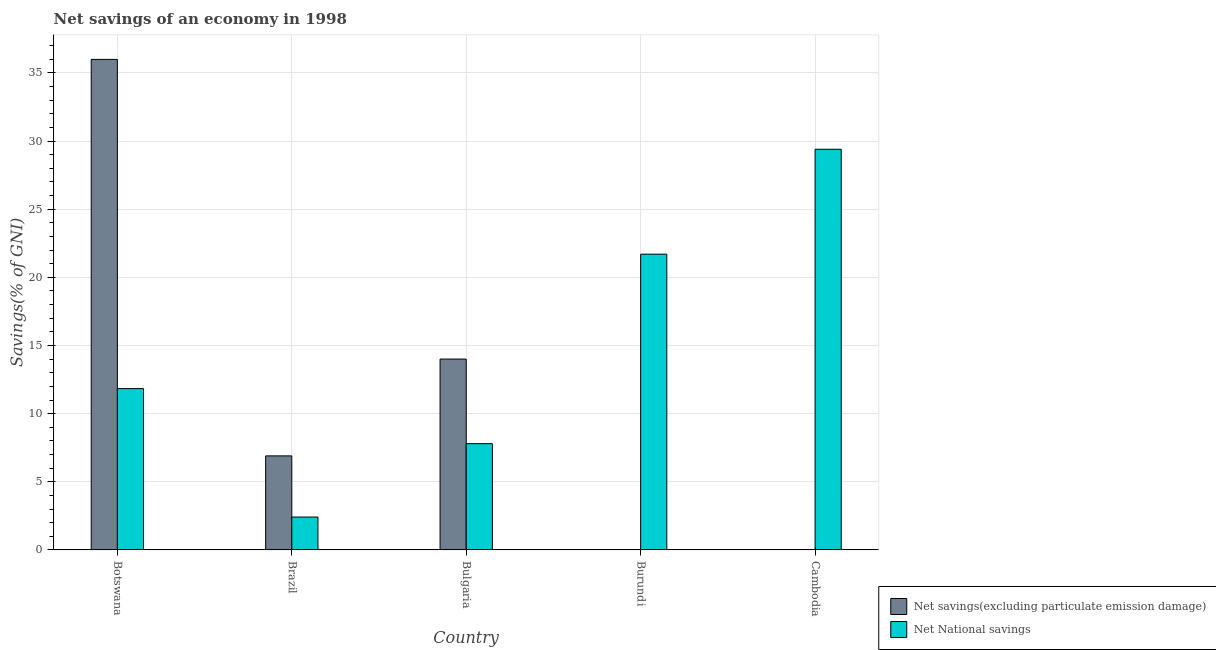How many different coloured bars are there?
Ensure brevity in your answer.  2. How many bars are there on the 3rd tick from the right?
Your answer should be very brief. 2. What is the net national savings in Brazil?
Make the answer very short. 2.41. Across all countries, what is the maximum net savings(excluding particulate emission damage)?
Make the answer very short. 35.99. In which country was the net national savings maximum?
Provide a short and direct response. Cambodia. What is the total net savings(excluding particulate emission damage) in the graph?
Offer a terse response. 56.89. What is the difference between the net national savings in Brazil and that in Bulgaria?
Your answer should be compact. -5.38. What is the difference between the net savings(excluding particulate emission damage) in Cambodia and the net national savings in Bulgaria?
Your answer should be compact. -7.8. What is the average net savings(excluding particulate emission damage) per country?
Your answer should be very brief. 11.38. What is the difference between the net savings(excluding particulate emission damage) and net national savings in Botswana?
Ensure brevity in your answer.  24.15. In how many countries, is the net national savings greater than 18 %?
Your answer should be compact. 2. What is the ratio of the net national savings in Botswana to that in Bulgaria?
Ensure brevity in your answer.  1.52. Is the net national savings in Bulgaria less than that in Cambodia?
Offer a terse response. Yes. What is the difference between the highest and the second highest net national savings?
Your answer should be very brief. 7.7. What is the difference between the highest and the lowest net national savings?
Your answer should be compact. 26.99. In how many countries, is the net savings(excluding particulate emission damage) greater than the average net savings(excluding particulate emission damage) taken over all countries?
Ensure brevity in your answer.  2. Is the sum of the net national savings in Brazil and Burundi greater than the maximum net savings(excluding particulate emission damage) across all countries?
Ensure brevity in your answer.  No. How many bars are there?
Your answer should be very brief. 8. Are all the bars in the graph horizontal?
Offer a terse response. No. How many countries are there in the graph?
Ensure brevity in your answer.  5. What is the difference between two consecutive major ticks on the Y-axis?
Offer a very short reply. 5. Are the values on the major ticks of Y-axis written in scientific E-notation?
Provide a succinct answer. No. Does the graph contain grids?
Ensure brevity in your answer.  Yes. How many legend labels are there?
Your answer should be very brief. 2. How are the legend labels stacked?
Make the answer very short. Vertical. What is the title of the graph?
Ensure brevity in your answer.  Net savings of an economy in 1998. What is the label or title of the X-axis?
Your answer should be compact. Country. What is the label or title of the Y-axis?
Give a very brief answer. Savings(% of GNI). What is the Savings(% of GNI) of Net savings(excluding particulate emission damage) in Botswana?
Provide a succinct answer. 35.99. What is the Savings(% of GNI) of Net National savings in Botswana?
Ensure brevity in your answer.  11.84. What is the Savings(% of GNI) of Net savings(excluding particulate emission damage) in Brazil?
Your answer should be compact. 6.9. What is the Savings(% of GNI) in Net National savings in Brazil?
Provide a short and direct response. 2.41. What is the Savings(% of GNI) in Net savings(excluding particulate emission damage) in Bulgaria?
Provide a succinct answer. 14. What is the Savings(% of GNI) in Net National savings in Bulgaria?
Make the answer very short. 7.8. What is the Savings(% of GNI) in Net National savings in Burundi?
Your answer should be very brief. 21.7. What is the Savings(% of GNI) in Net National savings in Cambodia?
Provide a succinct answer. 29.4. Across all countries, what is the maximum Savings(% of GNI) in Net savings(excluding particulate emission damage)?
Keep it short and to the point. 35.99. Across all countries, what is the maximum Savings(% of GNI) in Net National savings?
Make the answer very short. 29.4. Across all countries, what is the minimum Savings(% of GNI) in Net National savings?
Offer a terse response. 2.41. What is the total Savings(% of GNI) in Net savings(excluding particulate emission damage) in the graph?
Give a very brief answer. 56.89. What is the total Savings(% of GNI) of Net National savings in the graph?
Offer a very short reply. 73.14. What is the difference between the Savings(% of GNI) in Net savings(excluding particulate emission damage) in Botswana and that in Brazil?
Ensure brevity in your answer.  29.09. What is the difference between the Savings(% of GNI) in Net National savings in Botswana and that in Brazil?
Provide a short and direct response. 9.42. What is the difference between the Savings(% of GNI) of Net savings(excluding particulate emission damage) in Botswana and that in Bulgaria?
Provide a succinct answer. 21.99. What is the difference between the Savings(% of GNI) of Net National savings in Botswana and that in Bulgaria?
Your answer should be compact. 4.04. What is the difference between the Savings(% of GNI) in Net National savings in Botswana and that in Burundi?
Your answer should be compact. -9.86. What is the difference between the Savings(% of GNI) in Net National savings in Botswana and that in Cambodia?
Your answer should be very brief. -17.56. What is the difference between the Savings(% of GNI) in Net savings(excluding particulate emission damage) in Brazil and that in Bulgaria?
Make the answer very short. -7.1. What is the difference between the Savings(% of GNI) in Net National savings in Brazil and that in Bulgaria?
Keep it short and to the point. -5.38. What is the difference between the Savings(% of GNI) in Net National savings in Brazil and that in Burundi?
Your answer should be compact. -19.29. What is the difference between the Savings(% of GNI) in Net National savings in Brazil and that in Cambodia?
Your answer should be very brief. -26.99. What is the difference between the Savings(% of GNI) in Net National savings in Bulgaria and that in Burundi?
Ensure brevity in your answer.  -13.9. What is the difference between the Savings(% of GNI) of Net National savings in Bulgaria and that in Cambodia?
Make the answer very short. -21.6. What is the difference between the Savings(% of GNI) in Net National savings in Burundi and that in Cambodia?
Provide a short and direct response. -7.7. What is the difference between the Savings(% of GNI) of Net savings(excluding particulate emission damage) in Botswana and the Savings(% of GNI) of Net National savings in Brazil?
Ensure brevity in your answer.  33.58. What is the difference between the Savings(% of GNI) in Net savings(excluding particulate emission damage) in Botswana and the Savings(% of GNI) in Net National savings in Bulgaria?
Offer a very short reply. 28.19. What is the difference between the Savings(% of GNI) of Net savings(excluding particulate emission damage) in Botswana and the Savings(% of GNI) of Net National savings in Burundi?
Ensure brevity in your answer.  14.29. What is the difference between the Savings(% of GNI) in Net savings(excluding particulate emission damage) in Botswana and the Savings(% of GNI) in Net National savings in Cambodia?
Offer a very short reply. 6.59. What is the difference between the Savings(% of GNI) of Net savings(excluding particulate emission damage) in Brazil and the Savings(% of GNI) of Net National savings in Bulgaria?
Your answer should be compact. -0.9. What is the difference between the Savings(% of GNI) in Net savings(excluding particulate emission damage) in Brazil and the Savings(% of GNI) in Net National savings in Burundi?
Make the answer very short. -14.8. What is the difference between the Savings(% of GNI) in Net savings(excluding particulate emission damage) in Brazil and the Savings(% of GNI) in Net National savings in Cambodia?
Offer a terse response. -22.5. What is the difference between the Savings(% of GNI) in Net savings(excluding particulate emission damage) in Bulgaria and the Savings(% of GNI) in Net National savings in Burundi?
Provide a succinct answer. -7.7. What is the difference between the Savings(% of GNI) in Net savings(excluding particulate emission damage) in Bulgaria and the Savings(% of GNI) in Net National savings in Cambodia?
Ensure brevity in your answer.  -15.39. What is the average Savings(% of GNI) of Net savings(excluding particulate emission damage) per country?
Provide a succinct answer. 11.38. What is the average Savings(% of GNI) in Net National savings per country?
Ensure brevity in your answer.  14.63. What is the difference between the Savings(% of GNI) in Net savings(excluding particulate emission damage) and Savings(% of GNI) in Net National savings in Botswana?
Offer a terse response. 24.15. What is the difference between the Savings(% of GNI) of Net savings(excluding particulate emission damage) and Savings(% of GNI) of Net National savings in Brazil?
Offer a terse response. 4.49. What is the difference between the Savings(% of GNI) in Net savings(excluding particulate emission damage) and Savings(% of GNI) in Net National savings in Bulgaria?
Ensure brevity in your answer.  6.21. What is the ratio of the Savings(% of GNI) of Net savings(excluding particulate emission damage) in Botswana to that in Brazil?
Ensure brevity in your answer.  5.22. What is the ratio of the Savings(% of GNI) in Net National savings in Botswana to that in Brazil?
Provide a short and direct response. 4.91. What is the ratio of the Savings(% of GNI) of Net savings(excluding particulate emission damage) in Botswana to that in Bulgaria?
Provide a short and direct response. 2.57. What is the ratio of the Savings(% of GNI) in Net National savings in Botswana to that in Bulgaria?
Keep it short and to the point. 1.52. What is the ratio of the Savings(% of GNI) in Net National savings in Botswana to that in Burundi?
Your answer should be very brief. 0.55. What is the ratio of the Savings(% of GNI) of Net National savings in Botswana to that in Cambodia?
Offer a terse response. 0.4. What is the ratio of the Savings(% of GNI) in Net savings(excluding particulate emission damage) in Brazil to that in Bulgaria?
Give a very brief answer. 0.49. What is the ratio of the Savings(% of GNI) of Net National savings in Brazil to that in Bulgaria?
Provide a short and direct response. 0.31. What is the ratio of the Savings(% of GNI) in Net National savings in Brazil to that in Burundi?
Your answer should be compact. 0.11. What is the ratio of the Savings(% of GNI) of Net National savings in Brazil to that in Cambodia?
Offer a very short reply. 0.08. What is the ratio of the Savings(% of GNI) of Net National savings in Bulgaria to that in Burundi?
Provide a short and direct response. 0.36. What is the ratio of the Savings(% of GNI) in Net National savings in Bulgaria to that in Cambodia?
Ensure brevity in your answer.  0.27. What is the ratio of the Savings(% of GNI) in Net National savings in Burundi to that in Cambodia?
Your response must be concise. 0.74. What is the difference between the highest and the second highest Savings(% of GNI) of Net savings(excluding particulate emission damage)?
Offer a terse response. 21.99. What is the difference between the highest and the second highest Savings(% of GNI) in Net National savings?
Make the answer very short. 7.7. What is the difference between the highest and the lowest Savings(% of GNI) in Net savings(excluding particulate emission damage)?
Your response must be concise. 35.99. What is the difference between the highest and the lowest Savings(% of GNI) of Net National savings?
Keep it short and to the point. 26.99. 